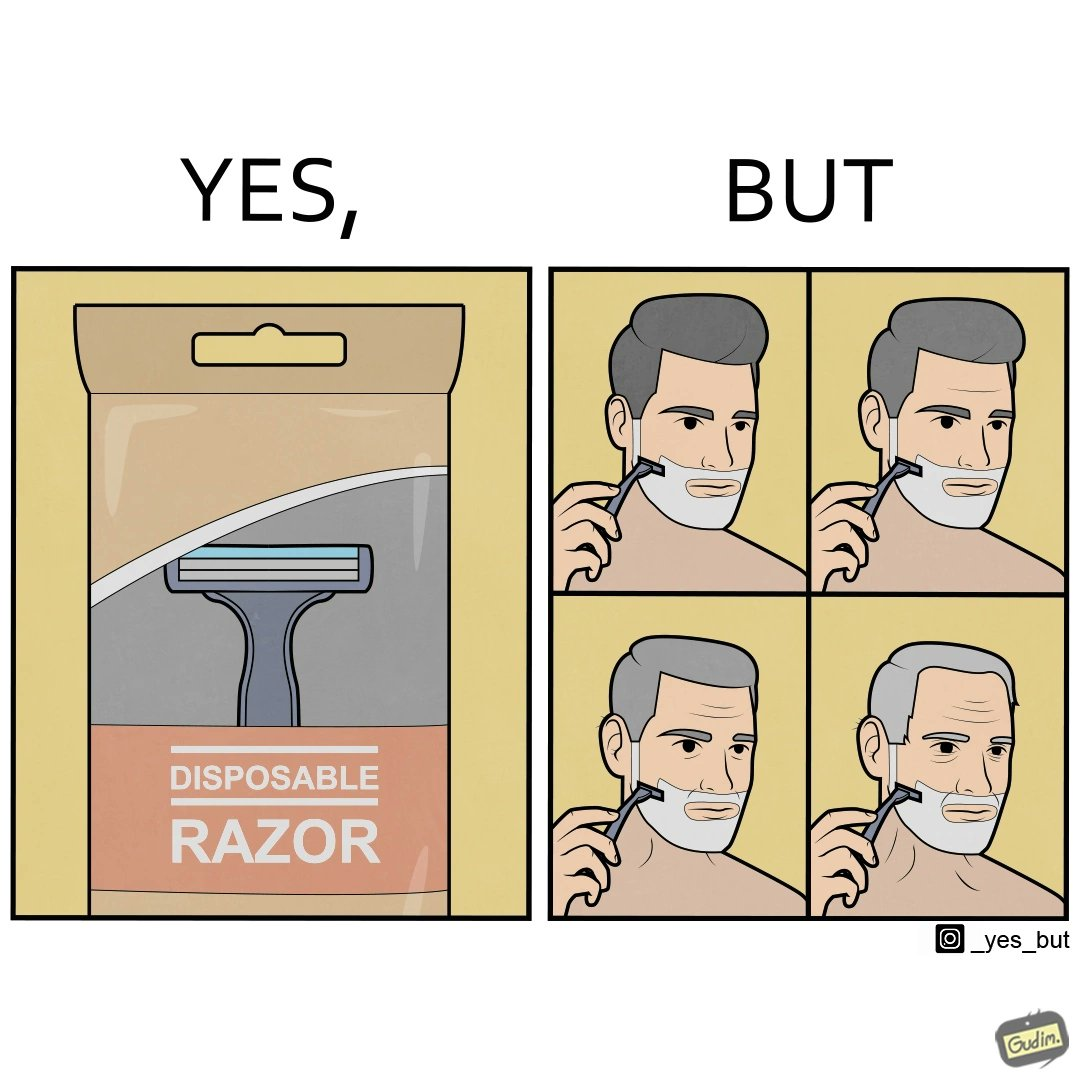Compare the left and right sides of this image. In the left part of the image: It is a disposable shaving razor In the right part of the image: It is a man shaving his beard with the same razor through multiple phases of his life 